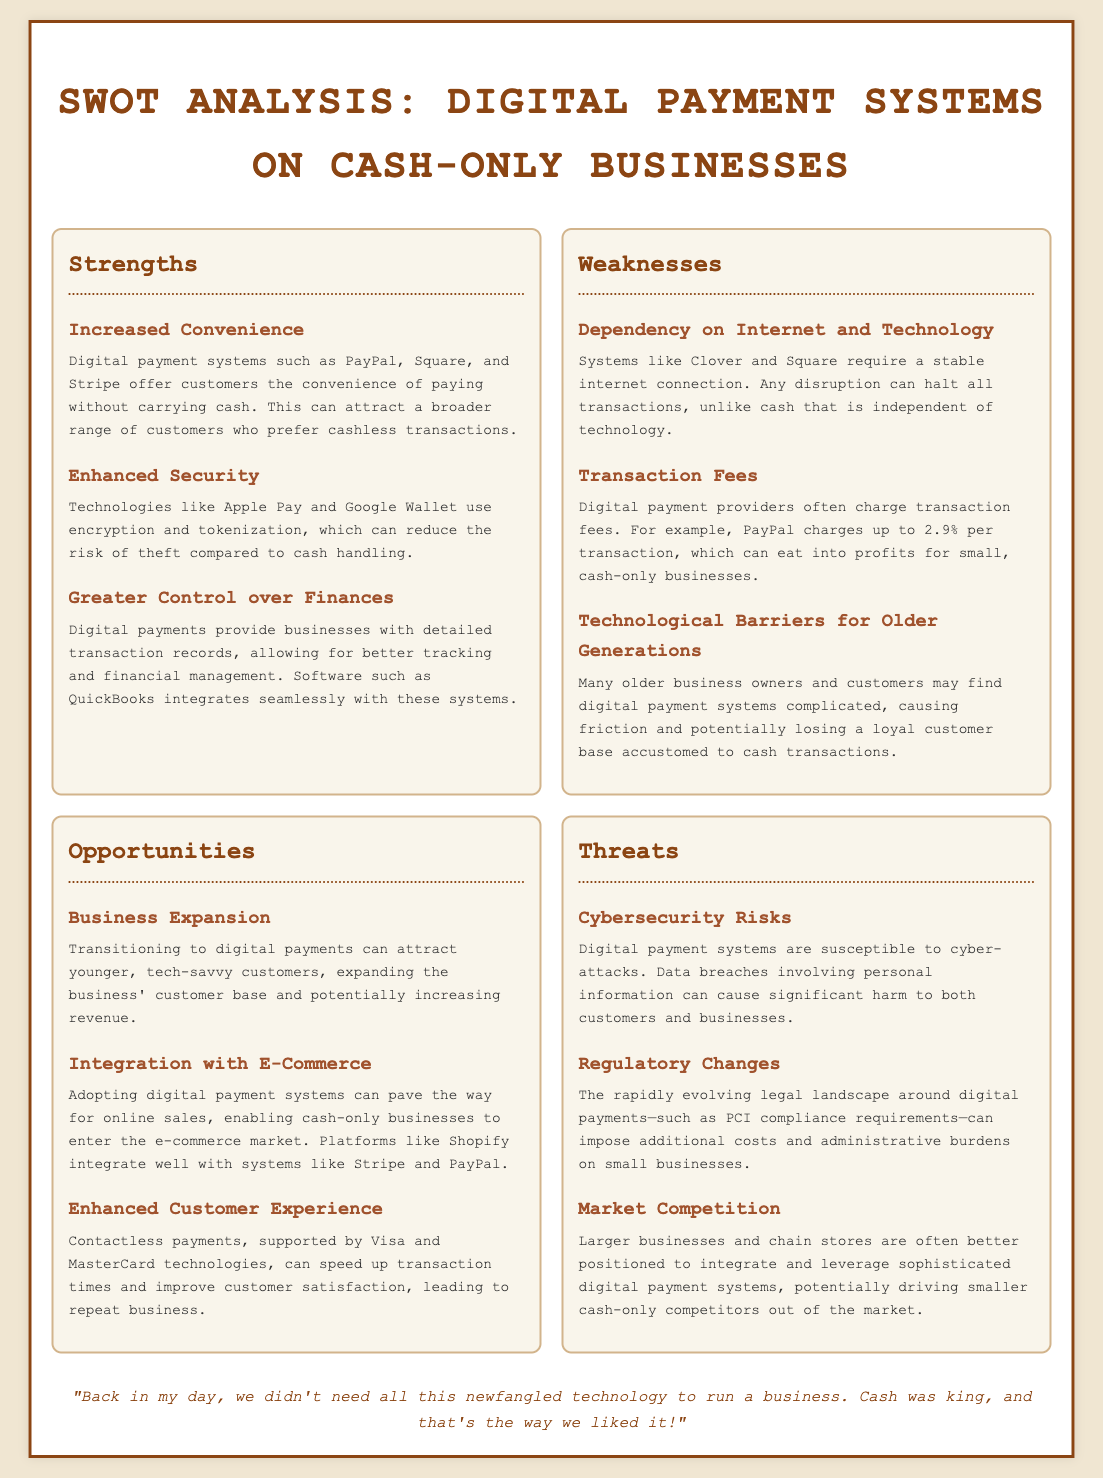what is one strength of digital payment systems? The text lists multiple strengths, one of which is "Increased Convenience," referring to the attraction of customers who prefer cashless transactions.
Answer: Increased Convenience what is one weakness related to customers in the document? The document mentions "Technological Barriers for Older Generations," highlighting that many older individuals may find digital payment systems complicated.
Answer: Technological Barriers for Older Generations what percentage does PayPal charge per transaction? The document states that "PayPal charges up to 2.9% per transaction," providing specific information on transaction fees.
Answer: 2.9% what opportunity is related to e-commerce? The SWOT analysis refers to "Integration with E-Commerce," explaining how adopting digital payment systems can facilitate online sales.
Answer: Integration with E-Commerce what is a threat mentioned in the document regarding cybersecurity? The document identifies "Cybersecurity Risks," explaining the susceptibility of digital payment systems to cyber-attacks and data breaches.
Answer: Cybersecurity Risks which technology offers enhanced security for digital payments? The analysis mentions technologies like "Apple Pay and Google Wallet," which use encryption and tokenization for enhanced security.
Answer: Apple Pay and Google Wallet 